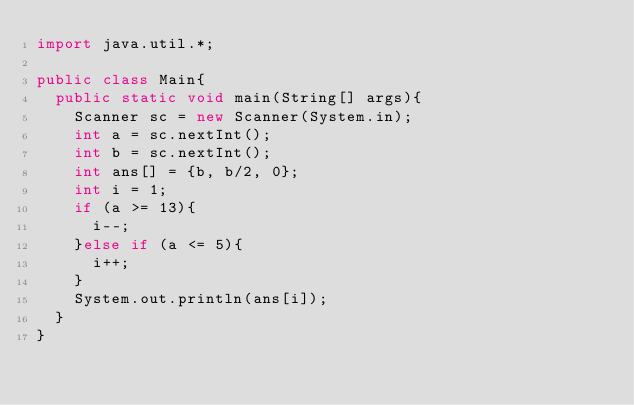<code> <loc_0><loc_0><loc_500><loc_500><_Java_>import java.util.*;

public class Main{
  public static void main(String[] args){
    Scanner sc = new Scanner(System.in);
    int a = sc.nextInt();
    int b = sc.nextInt();
    int ans[] = {b, b/2, 0};
    int i = 1;
    if (a >= 13){
      i--;
    }else if (a <= 5){
      i++;
    }
    System.out.println(ans[i]);
  }
}
</code> 